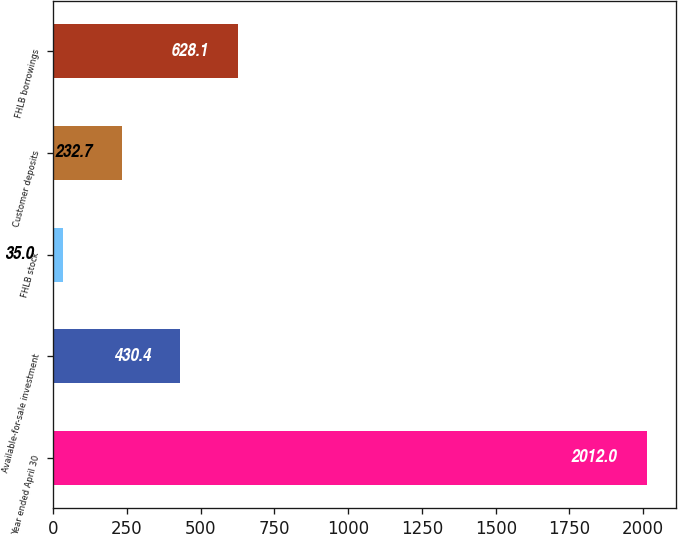Convert chart to OTSL. <chart><loc_0><loc_0><loc_500><loc_500><bar_chart><fcel>Year ended April 30<fcel>Available-for-sale investment<fcel>FHLB stock<fcel>Customer deposits<fcel>FHLB borrowings<nl><fcel>2012<fcel>430.4<fcel>35<fcel>232.7<fcel>628.1<nl></chart> 